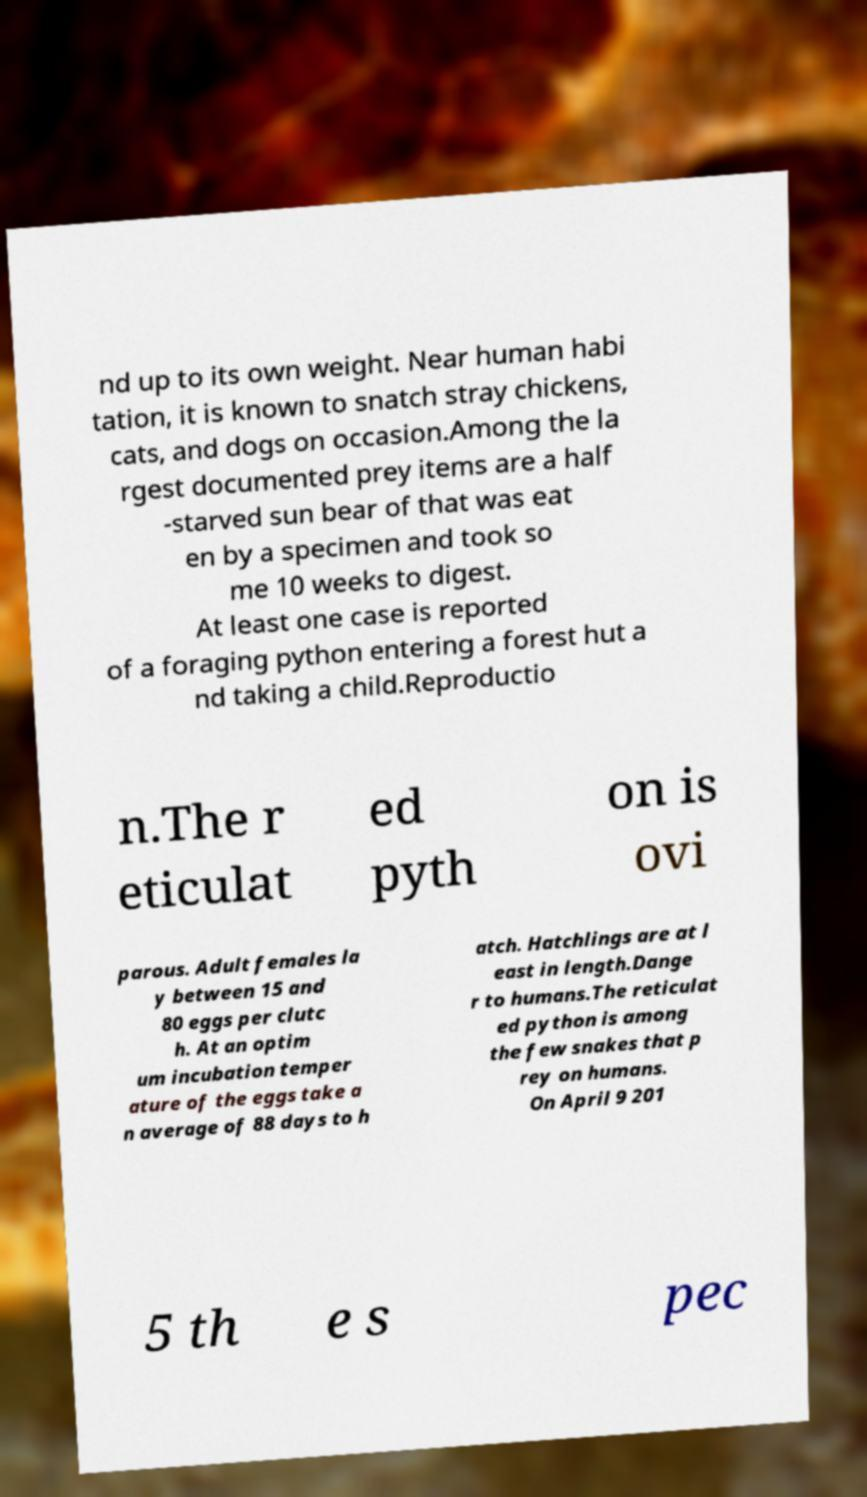Please read and relay the text visible in this image. What does it say? nd up to its own weight. Near human habi tation, it is known to snatch stray chickens, cats, and dogs on occasion.Among the la rgest documented prey items are a half -starved sun bear of that was eat en by a specimen and took so me 10 weeks to digest. At least one case is reported of a foraging python entering a forest hut a nd taking a child.Reproductio n.The r eticulat ed pyth on is ovi parous. Adult females la y between 15 and 80 eggs per clutc h. At an optim um incubation temper ature of the eggs take a n average of 88 days to h atch. Hatchlings are at l east in length.Dange r to humans.The reticulat ed python is among the few snakes that p rey on humans. On April 9 201 5 th e s pec 